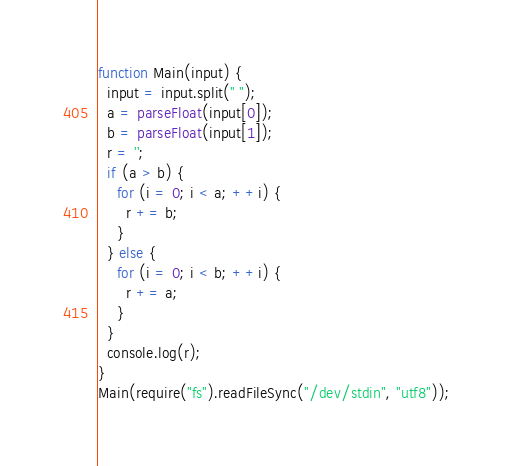Convert code to text. <code><loc_0><loc_0><loc_500><loc_500><_JavaScript_>function Main(input) {
  input = input.split(" ");
  a = parseFloat(input[0]);
  b = parseFloat(input[1]);
  r = '';
  if (a > b) {
    for (i = 0; i < a; ++i) {
      r += b;
    }
  } else {
    for (i = 0; i < b; ++i) {
      r += a;
    }
  }
  console.log(r);
}
Main(require("fs").readFileSync("/dev/stdin", "utf8"));</code> 